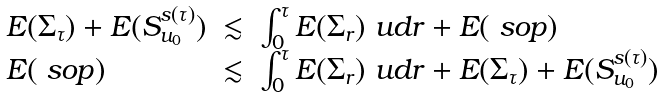Convert formula to latex. <formula><loc_0><loc_0><loc_500><loc_500>\begin{array} { l c l } E ( \Sigma _ { \tau } ) + E ( S _ { u _ { 0 } } ^ { s ( \tau ) } ) & \lesssim & \int _ { 0 } ^ { \tau } E ( \Sigma _ { r } ) \ u d r + E ( \ s o p ) \\ E ( \ s o p ) & \lesssim & \int _ { 0 } ^ { \tau } E ( \Sigma _ { r } ) \ u d r + E ( \Sigma _ { \tau } ) + E ( S _ { u _ { 0 } } ^ { s ( \tau ) } ) \\ \end{array}</formula> 